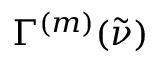<formula> <loc_0><loc_0><loc_500><loc_500>\Gamma ^ { ( m ) } ( \tilde { \nu } )</formula> 